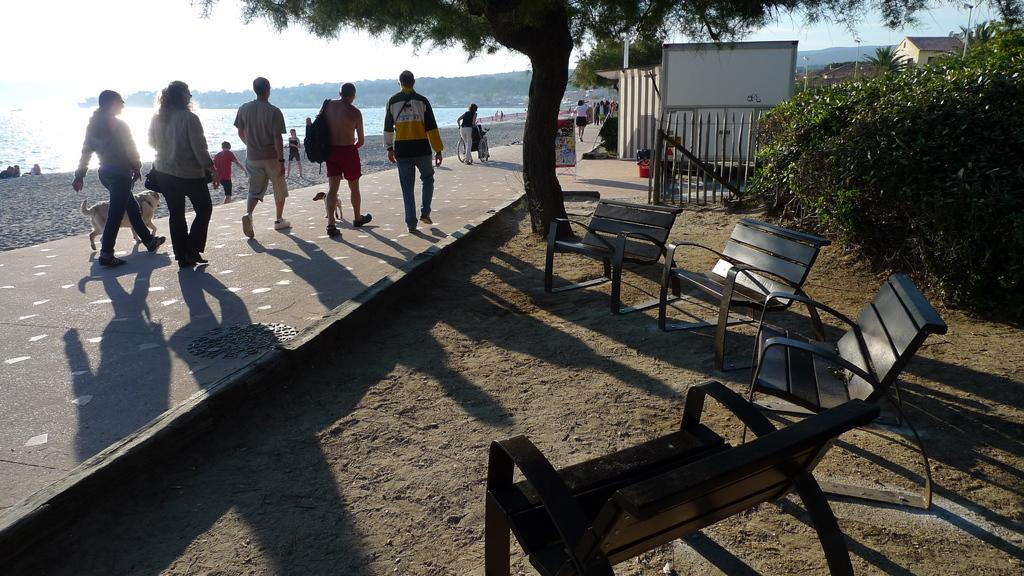How many people are in the image? There is a group of people in the image. What other living creatures are present in the image? There are two dogs in the image. What are the people and dogs doing in the image? The people and dogs are walking in the street. What type of outdoor furniture can be seen in the image? There are benches in the sand in the image. What type of vegetation is present in the image? There are plants in the image. What type of building can be seen in the image? There is a house in the image. What part of the natural environment is visible in the image? The sky is visible in the image. What type of geographical feature is present in the image? There are mountains in the image. What type of recreational area is present in the image? There is a beach in the image. What type of paper is being used by the dogs to play with on the beach? There is no paper present in the image, and the dogs are not playing with any toys. 